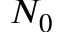<formula> <loc_0><loc_0><loc_500><loc_500>N _ { 0 }</formula> 